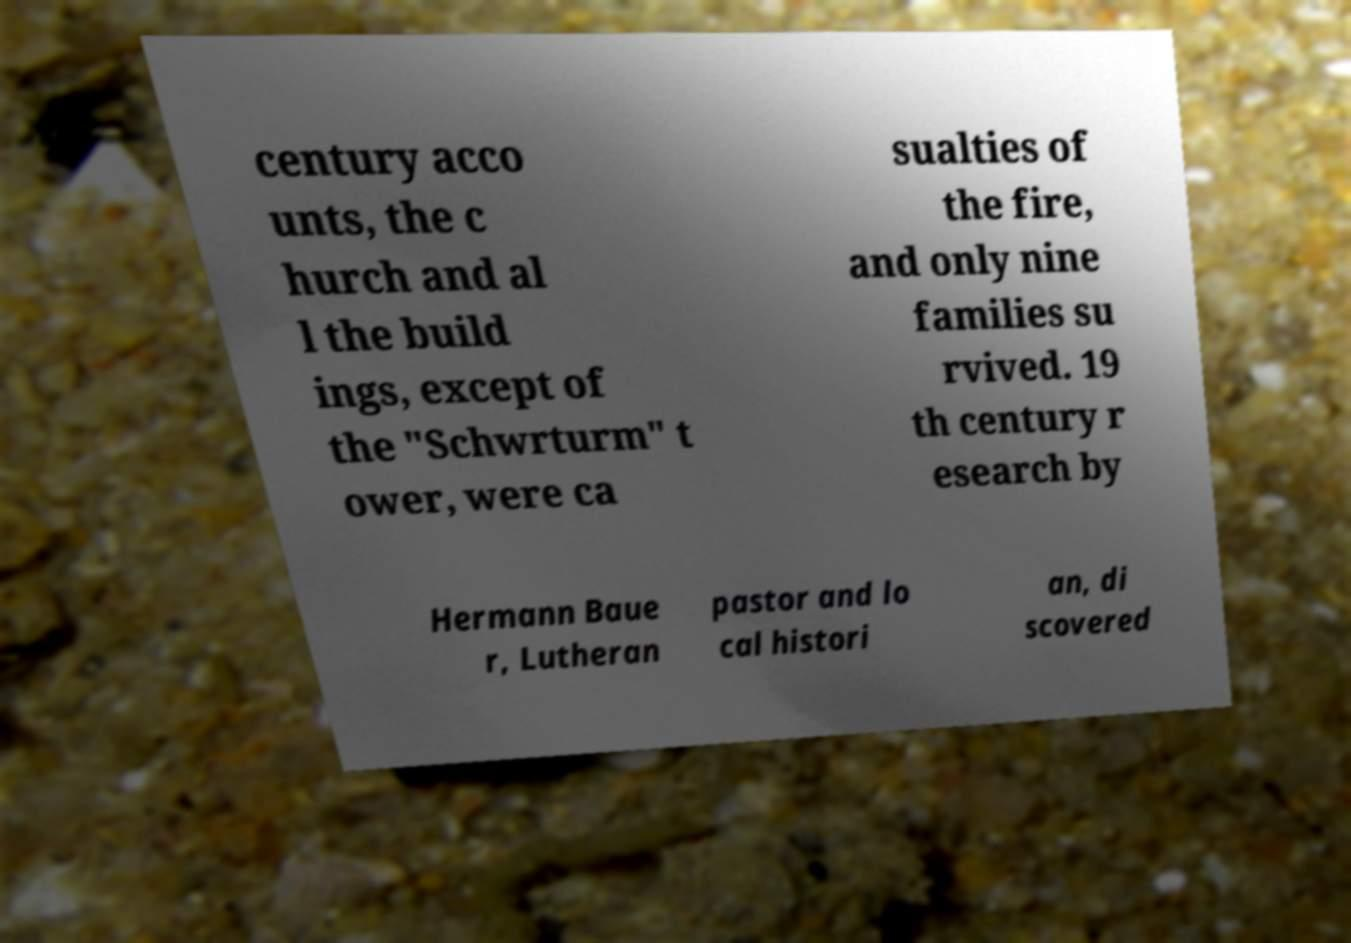Could you assist in decoding the text presented in this image and type it out clearly? century acco unts, the c hurch and al l the build ings, except of the "Schwrturm" t ower, were ca sualties of the fire, and only nine families su rvived. 19 th century r esearch by Hermann Baue r, Lutheran pastor and lo cal histori an, di scovered 